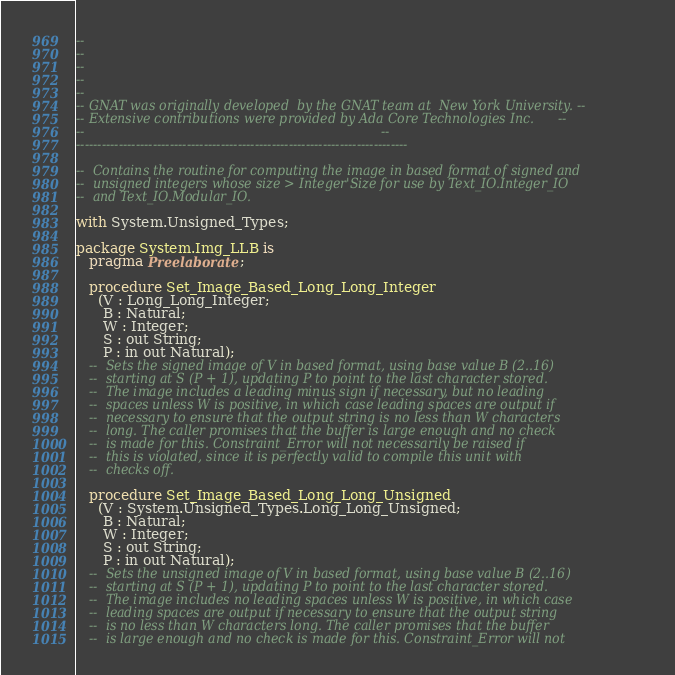<code> <loc_0><loc_0><loc_500><loc_500><_Ada_>--
--
--
--
--
-- GNAT was originally developed  by the GNAT team at  New York University. --
-- Extensive contributions were provided by Ada Core Technologies Inc.      --
--                                                                          --
------------------------------------------------------------------------------

--  Contains the routine for computing the image in based format of signed and
--  unsigned integers whose size > Integer'Size for use by Text_IO.Integer_IO
--  and Text_IO.Modular_IO.

with System.Unsigned_Types;

package System.Img_LLB is
   pragma Preelaborate;

   procedure Set_Image_Based_Long_Long_Integer
     (V : Long_Long_Integer;
      B : Natural;
      W : Integer;
      S : out String;
      P : in out Natural);
   --  Sets the signed image of V in based format, using base value B (2..16)
   --  starting at S (P + 1), updating P to point to the last character stored.
   --  The image includes a leading minus sign if necessary, but no leading
   --  spaces unless W is positive, in which case leading spaces are output if
   --  necessary to ensure that the output string is no less than W characters
   --  long. The caller promises that the buffer is large enough and no check
   --  is made for this. Constraint_Error will not necessarily be raised if
   --  this is violated, since it is perfectly valid to compile this unit with
   --  checks off.

   procedure Set_Image_Based_Long_Long_Unsigned
     (V : System.Unsigned_Types.Long_Long_Unsigned;
      B : Natural;
      W : Integer;
      S : out String;
      P : in out Natural);
   --  Sets the unsigned image of V in based format, using base value B (2..16)
   --  starting at S (P + 1), updating P to point to the last character stored.
   --  The image includes no leading spaces unless W is positive, in which case
   --  leading spaces are output if necessary to ensure that the output string
   --  is no less than W characters long. The caller promises that the buffer
   --  is large enough and no check is made for this. Constraint_Error will not</code> 